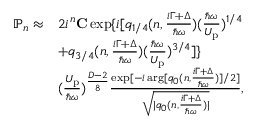<formula> <loc_0><loc_0><loc_500><loc_500>\begin{array} { r l } { \mathbb { P } _ { n } \approx } & { 2 i ^ { n } { C } \exp \{ i [ q _ { 1 / 4 } ( n , \frac { i \Gamma + \Delta } { \hbar { \omega } } ) ( \frac { \hbar { \omega } } { U _ { p } } ) ^ { 1 / 4 } } \\ & { + q _ { 3 / 4 } ( n , \frac { i \Gamma + \Delta } { \hbar { \omega } } ) ( \frac { \hbar { \omega } } { U _ { p } } ) ^ { 3 / 4 } ] \} } \\ & { ( \frac { U _ { p } } { \hbar { \omega } } ) ^ { \frac { D - 2 } { 8 } } \frac { \exp [ - i \arg [ q _ { 0 } ( n , \frac { i \Gamma + \Delta } { \hbar { \omega } } ) ] / 2 ] } { \sqrt { | q _ { 0 } ( n , \frac { i \Gamma + \Delta } { \hbar { \omega } } ) | } } , } \end{array}</formula> 